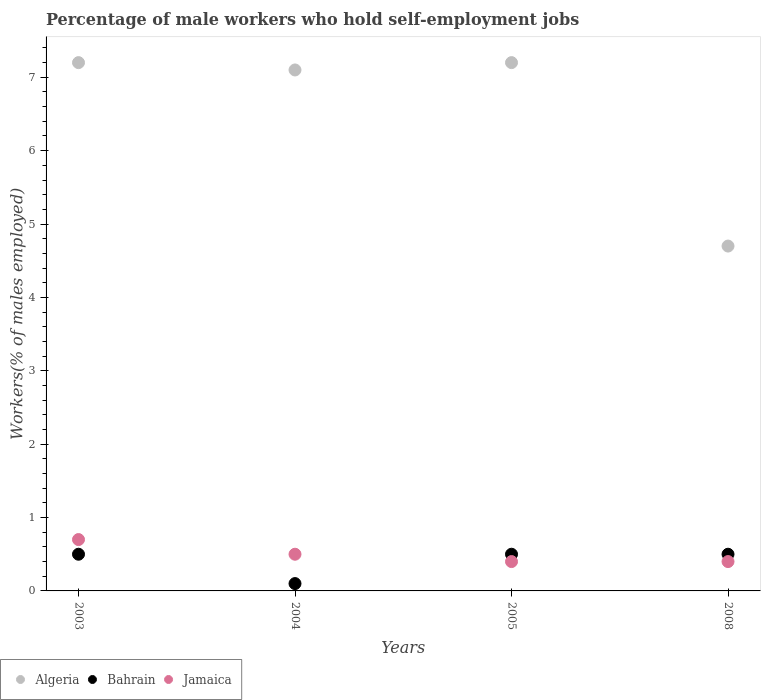Is the number of dotlines equal to the number of legend labels?
Your answer should be compact. Yes. What is the percentage of self-employed male workers in Algeria in 2005?
Keep it short and to the point. 7.2. Across all years, what is the maximum percentage of self-employed male workers in Bahrain?
Ensure brevity in your answer.  0.5. Across all years, what is the minimum percentage of self-employed male workers in Bahrain?
Make the answer very short. 0.1. What is the total percentage of self-employed male workers in Algeria in the graph?
Offer a terse response. 26.2. What is the difference between the percentage of self-employed male workers in Jamaica in 2004 and that in 2008?
Your answer should be compact. 0.1. What is the difference between the percentage of self-employed male workers in Algeria in 2004 and the percentage of self-employed male workers in Bahrain in 2008?
Make the answer very short. 6.6. What is the average percentage of self-employed male workers in Jamaica per year?
Your answer should be very brief. 0.5. In the year 2005, what is the difference between the percentage of self-employed male workers in Bahrain and percentage of self-employed male workers in Jamaica?
Provide a succinct answer. 0.1. In how many years, is the percentage of self-employed male workers in Jamaica greater than 5.4 %?
Your response must be concise. 0. What is the ratio of the percentage of self-employed male workers in Bahrain in 2003 to that in 2008?
Provide a succinct answer. 1. What is the difference between the highest and the lowest percentage of self-employed male workers in Bahrain?
Provide a succinct answer. 0.4. Is it the case that in every year, the sum of the percentage of self-employed male workers in Algeria and percentage of self-employed male workers in Jamaica  is greater than the percentage of self-employed male workers in Bahrain?
Offer a very short reply. Yes. How many dotlines are there?
Provide a succinct answer. 3. What is the difference between two consecutive major ticks on the Y-axis?
Make the answer very short. 1. Where does the legend appear in the graph?
Give a very brief answer. Bottom left. How many legend labels are there?
Provide a succinct answer. 3. What is the title of the graph?
Provide a succinct answer. Percentage of male workers who hold self-employment jobs. What is the label or title of the X-axis?
Give a very brief answer. Years. What is the label or title of the Y-axis?
Offer a very short reply. Workers(% of males employed). What is the Workers(% of males employed) of Algeria in 2003?
Your answer should be compact. 7.2. What is the Workers(% of males employed) of Jamaica in 2003?
Your answer should be very brief. 0.7. What is the Workers(% of males employed) in Algeria in 2004?
Ensure brevity in your answer.  7.1. What is the Workers(% of males employed) of Bahrain in 2004?
Offer a terse response. 0.1. What is the Workers(% of males employed) of Jamaica in 2004?
Your answer should be compact. 0.5. What is the Workers(% of males employed) of Algeria in 2005?
Ensure brevity in your answer.  7.2. What is the Workers(% of males employed) in Bahrain in 2005?
Make the answer very short. 0.5. What is the Workers(% of males employed) of Jamaica in 2005?
Offer a terse response. 0.4. What is the Workers(% of males employed) in Algeria in 2008?
Your response must be concise. 4.7. What is the Workers(% of males employed) of Jamaica in 2008?
Your answer should be very brief. 0.4. Across all years, what is the maximum Workers(% of males employed) in Algeria?
Your answer should be very brief. 7.2. Across all years, what is the maximum Workers(% of males employed) of Bahrain?
Your answer should be very brief. 0.5. Across all years, what is the maximum Workers(% of males employed) in Jamaica?
Your answer should be very brief. 0.7. Across all years, what is the minimum Workers(% of males employed) in Algeria?
Your response must be concise. 4.7. Across all years, what is the minimum Workers(% of males employed) in Bahrain?
Your answer should be compact. 0.1. Across all years, what is the minimum Workers(% of males employed) of Jamaica?
Ensure brevity in your answer.  0.4. What is the total Workers(% of males employed) in Algeria in the graph?
Provide a succinct answer. 26.2. What is the difference between the Workers(% of males employed) of Jamaica in 2003 and that in 2004?
Provide a succinct answer. 0.2. What is the difference between the Workers(% of males employed) of Jamaica in 2003 and that in 2005?
Offer a very short reply. 0.3. What is the difference between the Workers(% of males employed) of Bahrain in 2004 and that in 2005?
Your answer should be compact. -0.4. What is the difference between the Workers(% of males employed) in Jamaica in 2004 and that in 2005?
Give a very brief answer. 0.1. What is the difference between the Workers(% of males employed) in Bahrain in 2004 and that in 2008?
Offer a very short reply. -0.4. What is the difference between the Workers(% of males employed) in Bahrain in 2005 and that in 2008?
Offer a very short reply. 0. What is the difference between the Workers(% of males employed) of Algeria in 2003 and the Workers(% of males employed) of Jamaica in 2004?
Your response must be concise. 6.7. What is the difference between the Workers(% of males employed) in Bahrain in 2003 and the Workers(% of males employed) in Jamaica in 2004?
Give a very brief answer. 0. What is the difference between the Workers(% of males employed) in Algeria in 2003 and the Workers(% of males employed) in Bahrain in 2005?
Make the answer very short. 6.7. What is the difference between the Workers(% of males employed) of Algeria in 2003 and the Workers(% of males employed) of Jamaica in 2005?
Make the answer very short. 6.8. What is the difference between the Workers(% of males employed) of Bahrain in 2003 and the Workers(% of males employed) of Jamaica in 2005?
Provide a short and direct response. 0.1. What is the difference between the Workers(% of males employed) of Algeria in 2003 and the Workers(% of males employed) of Jamaica in 2008?
Keep it short and to the point. 6.8. What is the difference between the Workers(% of males employed) of Algeria in 2004 and the Workers(% of males employed) of Bahrain in 2005?
Ensure brevity in your answer.  6.6. What is the difference between the Workers(% of males employed) in Algeria in 2004 and the Workers(% of males employed) in Jamaica in 2005?
Give a very brief answer. 6.7. What is the difference between the Workers(% of males employed) of Algeria in 2004 and the Workers(% of males employed) of Jamaica in 2008?
Keep it short and to the point. 6.7. What is the difference between the Workers(% of males employed) in Algeria in 2005 and the Workers(% of males employed) in Jamaica in 2008?
Give a very brief answer. 6.8. What is the average Workers(% of males employed) in Algeria per year?
Make the answer very short. 6.55. What is the average Workers(% of males employed) in Bahrain per year?
Make the answer very short. 0.4. In the year 2003, what is the difference between the Workers(% of males employed) of Algeria and Workers(% of males employed) of Bahrain?
Keep it short and to the point. 6.7. In the year 2003, what is the difference between the Workers(% of males employed) of Bahrain and Workers(% of males employed) of Jamaica?
Offer a very short reply. -0.2. In the year 2004, what is the difference between the Workers(% of males employed) of Algeria and Workers(% of males employed) of Bahrain?
Give a very brief answer. 7. In the year 2005, what is the difference between the Workers(% of males employed) of Algeria and Workers(% of males employed) of Jamaica?
Offer a terse response. 6.8. In the year 2008, what is the difference between the Workers(% of males employed) in Bahrain and Workers(% of males employed) in Jamaica?
Provide a succinct answer. 0.1. What is the ratio of the Workers(% of males employed) of Algeria in 2003 to that in 2004?
Keep it short and to the point. 1.01. What is the ratio of the Workers(% of males employed) in Bahrain in 2003 to that in 2004?
Provide a short and direct response. 5. What is the ratio of the Workers(% of males employed) in Bahrain in 2003 to that in 2005?
Your answer should be compact. 1. What is the ratio of the Workers(% of males employed) of Algeria in 2003 to that in 2008?
Your response must be concise. 1.53. What is the ratio of the Workers(% of males employed) of Jamaica in 2003 to that in 2008?
Your response must be concise. 1.75. What is the ratio of the Workers(% of males employed) in Algeria in 2004 to that in 2005?
Your response must be concise. 0.99. What is the ratio of the Workers(% of males employed) in Bahrain in 2004 to that in 2005?
Offer a very short reply. 0.2. What is the ratio of the Workers(% of males employed) of Algeria in 2004 to that in 2008?
Ensure brevity in your answer.  1.51. What is the ratio of the Workers(% of males employed) in Bahrain in 2004 to that in 2008?
Your answer should be very brief. 0.2. What is the ratio of the Workers(% of males employed) in Jamaica in 2004 to that in 2008?
Offer a very short reply. 1.25. What is the ratio of the Workers(% of males employed) in Algeria in 2005 to that in 2008?
Your answer should be compact. 1.53. What is the ratio of the Workers(% of males employed) of Bahrain in 2005 to that in 2008?
Provide a short and direct response. 1. What is the difference between the highest and the second highest Workers(% of males employed) in Algeria?
Keep it short and to the point. 0. What is the difference between the highest and the second highest Workers(% of males employed) of Bahrain?
Provide a succinct answer. 0. What is the difference between the highest and the second highest Workers(% of males employed) of Jamaica?
Offer a terse response. 0.2. What is the difference between the highest and the lowest Workers(% of males employed) of Algeria?
Offer a terse response. 2.5. What is the difference between the highest and the lowest Workers(% of males employed) of Bahrain?
Offer a very short reply. 0.4. What is the difference between the highest and the lowest Workers(% of males employed) of Jamaica?
Offer a terse response. 0.3. 